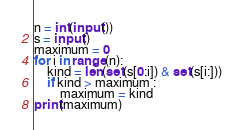<code> <loc_0><loc_0><loc_500><loc_500><_Python_>n = int(input())
s = input()
maximum = 0
for i in range(n):
    kind = len(set(s[0:i]) & set(s[i:]))
    if kind > maximum :
        maximum = kind
print(maximum)</code> 